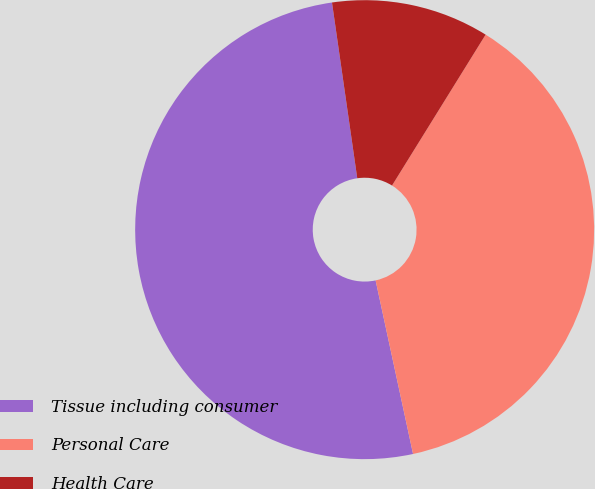Convert chart. <chart><loc_0><loc_0><loc_500><loc_500><pie_chart><fcel>Tissue including consumer<fcel>Personal Care<fcel>Health Care<nl><fcel>51.11%<fcel>37.78%<fcel>11.11%<nl></chart> 